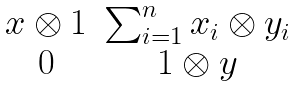<formula> <loc_0><loc_0><loc_500><loc_500>\begin{matrix} x \otimes 1 & \sum _ { i = 1 } ^ { n } x _ { i } \otimes y _ { i } \\ 0 & 1 \otimes y \end{matrix}</formula> 